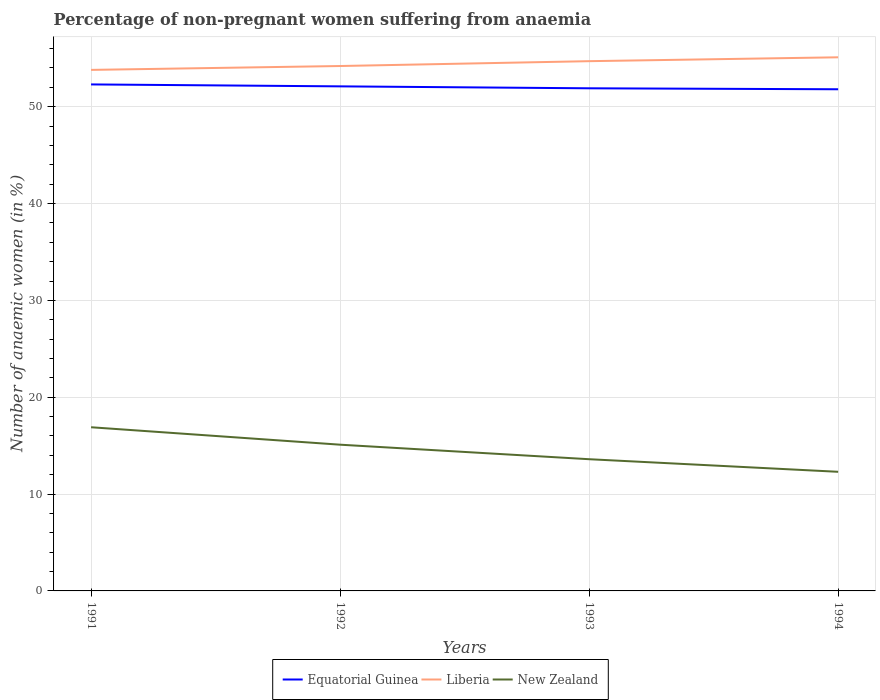Is the number of lines equal to the number of legend labels?
Offer a terse response. Yes. Across all years, what is the maximum percentage of non-pregnant women suffering from anaemia in Equatorial Guinea?
Make the answer very short. 51.8. What is the total percentage of non-pregnant women suffering from anaemia in New Zealand in the graph?
Offer a very short reply. 3.3. What is the difference between the highest and the second highest percentage of non-pregnant women suffering from anaemia in Liberia?
Your answer should be very brief. 1.3. What is the difference between the highest and the lowest percentage of non-pregnant women suffering from anaemia in New Zealand?
Ensure brevity in your answer.  2. Is the percentage of non-pregnant women suffering from anaemia in Liberia strictly greater than the percentage of non-pregnant women suffering from anaemia in New Zealand over the years?
Provide a short and direct response. No. How many lines are there?
Offer a very short reply. 3. What is the difference between two consecutive major ticks on the Y-axis?
Make the answer very short. 10. Does the graph contain any zero values?
Provide a short and direct response. No. Where does the legend appear in the graph?
Offer a terse response. Bottom center. How are the legend labels stacked?
Offer a terse response. Horizontal. What is the title of the graph?
Your response must be concise. Percentage of non-pregnant women suffering from anaemia. What is the label or title of the X-axis?
Give a very brief answer. Years. What is the label or title of the Y-axis?
Ensure brevity in your answer.  Number of anaemic women (in %). What is the Number of anaemic women (in %) of Equatorial Guinea in 1991?
Your answer should be compact. 52.3. What is the Number of anaemic women (in %) of Liberia in 1991?
Your answer should be compact. 53.8. What is the Number of anaemic women (in %) of New Zealand in 1991?
Make the answer very short. 16.9. What is the Number of anaemic women (in %) of Equatorial Guinea in 1992?
Offer a terse response. 52.1. What is the Number of anaemic women (in %) of Liberia in 1992?
Your response must be concise. 54.2. What is the Number of anaemic women (in %) in Equatorial Guinea in 1993?
Offer a very short reply. 51.9. What is the Number of anaemic women (in %) in Liberia in 1993?
Your answer should be compact. 54.7. What is the Number of anaemic women (in %) in New Zealand in 1993?
Ensure brevity in your answer.  13.6. What is the Number of anaemic women (in %) in Equatorial Guinea in 1994?
Offer a terse response. 51.8. What is the Number of anaemic women (in %) in Liberia in 1994?
Give a very brief answer. 55.1. Across all years, what is the maximum Number of anaemic women (in %) of Equatorial Guinea?
Provide a short and direct response. 52.3. Across all years, what is the maximum Number of anaemic women (in %) in Liberia?
Offer a very short reply. 55.1. Across all years, what is the minimum Number of anaemic women (in %) of Equatorial Guinea?
Make the answer very short. 51.8. Across all years, what is the minimum Number of anaemic women (in %) of Liberia?
Offer a very short reply. 53.8. What is the total Number of anaemic women (in %) in Equatorial Guinea in the graph?
Your answer should be very brief. 208.1. What is the total Number of anaemic women (in %) of Liberia in the graph?
Give a very brief answer. 217.8. What is the total Number of anaemic women (in %) in New Zealand in the graph?
Ensure brevity in your answer.  57.9. What is the difference between the Number of anaemic women (in %) in Equatorial Guinea in 1991 and that in 1992?
Offer a very short reply. 0.2. What is the difference between the Number of anaemic women (in %) in Liberia in 1991 and that in 1992?
Your answer should be very brief. -0.4. What is the difference between the Number of anaemic women (in %) in New Zealand in 1991 and that in 1992?
Ensure brevity in your answer.  1.8. What is the difference between the Number of anaemic women (in %) of New Zealand in 1991 and that in 1993?
Make the answer very short. 3.3. What is the difference between the Number of anaemic women (in %) of New Zealand in 1991 and that in 1994?
Ensure brevity in your answer.  4.6. What is the difference between the Number of anaemic women (in %) of Equatorial Guinea in 1992 and that in 1993?
Offer a very short reply. 0.2. What is the difference between the Number of anaemic women (in %) of Liberia in 1992 and that in 1993?
Keep it short and to the point. -0.5. What is the difference between the Number of anaemic women (in %) of New Zealand in 1992 and that in 1993?
Ensure brevity in your answer.  1.5. What is the difference between the Number of anaemic women (in %) of Equatorial Guinea in 1993 and that in 1994?
Provide a succinct answer. 0.1. What is the difference between the Number of anaemic women (in %) of Equatorial Guinea in 1991 and the Number of anaemic women (in %) of New Zealand in 1992?
Your answer should be very brief. 37.2. What is the difference between the Number of anaemic women (in %) of Liberia in 1991 and the Number of anaemic women (in %) of New Zealand in 1992?
Your answer should be very brief. 38.7. What is the difference between the Number of anaemic women (in %) of Equatorial Guinea in 1991 and the Number of anaemic women (in %) of Liberia in 1993?
Provide a short and direct response. -2.4. What is the difference between the Number of anaemic women (in %) of Equatorial Guinea in 1991 and the Number of anaemic women (in %) of New Zealand in 1993?
Provide a succinct answer. 38.7. What is the difference between the Number of anaemic women (in %) of Liberia in 1991 and the Number of anaemic women (in %) of New Zealand in 1993?
Keep it short and to the point. 40.2. What is the difference between the Number of anaemic women (in %) of Equatorial Guinea in 1991 and the Number of anaemic women (in %) of Liberia in 1994?
Give a very brief answer. -2.8. What is the difference between the Number of anaemic women (in %) of Equatorial Guinea in 1991 and the Number of anaemic women (in %) of New Zealand in 1994?
Your response must be concise. 40. What is the difference between the Number of anaemic women (in %) in Liberia in 1991 and the Number of anaemic women (in %) in New Zealand in 1994?
Offer a very short reply. 41.5. What is the difference between the Number of anaemic women (in %) of Equatorial Guinea in 1992 and the Number of anaemic women (in %) of Liberia in 1993?
Your response must be concise. -2.6. What is the difference between the Number of anaemic women (in %) in Equatorial Guinea in 1992 and the Number of anaemic women (in %) in New Zealand in 1993?
Provide a short and direct response. 38.5. What is the difference between the Number of anaemic women (in %) in Liberia in 1992 and the Number of anaemic women (in %) in New Zealand in 1993?
Ensure brevity in your answer.  40.6. What is the difference between the Number of anaemic women (in %) of Equatorial Guinea in 1992 and the Number of anaemic women (in %) of New Zealand in 1994?
Provide a succinct answer. 39.8. What is the difference between the Number of anaemic women (in %) of Liberia in 1992 and the Number of anaemic women (in %) of New Zealand in 1994?
Provide a short and direct response. 41.9. What is the difference between the Number of anaemic women (in %) of Equatorial Guinea in 1993 and the Number of anaemic women (in %) of Liberia in 1994?
Offer a terse response. -3.2. What is the difference between the Number of anaemic women (in %) in Equatorial Guinea in 1993 and the Number of anaemic women (in %) in New Zealand in 1994?
Ensure brevity in your answer.  39.6. What is the difference between the Number of anaemic women (in %) in Liberia in 1993 and the Number of anaemic women (in %) in New Zealand in 1994?
Make the answer very short. 42.4. What is the average Number of anaemic women (in %) in Equatorial Guinea per year?
Make the answer very short. 52.02. What is the average Number of anaemic women (in %) of Liberia per year?
Ensure brevity in your answer.  54.45. What is the average Number of anaemic women (in %) in New Zealand per year?
Your answer should be very brief. 14.47. In the year 1991, what is the difference between the Number of anaemic women (in %) in Equatorial Guinea and Number of anaemic women (in %) in Liberia?
Offer a terse response. -1.5. In the year 1991, what is the difference between the Number of anaemic women (in %) in Equatorial Guinea and Number of anaemic women (in %) in New Zealand?
Offer a terse response. 35.4. In the year 1991, what is the difference between the Number of anaemic women (in %) in Liberia and Number of anaemic women (in %) in New Zealand?
Offer a terse response. 36.9. In the year 1992, what is the difference between the Number of anaemic women (in %) of Liberia and Number of anaemic women (in %) of New Zealand?
Provide a succinct answer. 39.1. In the year 1993, what is the difference between the Number of anaemic women (in %) in Equatorial Guinea and Number of anaemic women (in %) in Liberia?
Ensure brevity in your answer.  -2.8. In the year 1993, what is the difference between the Number of anaemic women (in %) of Equatorial Guinea and Number of anaemic women (in %) of New Zealand?
Keep it short and to the point. 38.3. In the year 1993, what is the difference between the Number of anaemic women (in %) of Liberia and Number of anaemic women (in %) of New Zealand?
Provide a succinct answer. 41.1. In the year 1994, what is the difference between the Number of anaemic women (in %) of Equatorial Guinea and Number of anaemic women (in %) of New Zealand?
Make the answer very short. 39.5. In the year 1994, what is the difference between the Number of anaemic women (in %) in Liberia and Number of anaemic women (in %) in New Zealand?
Provide a short and direct response. 42.8. What is the ratio of the Number of anaemic women (in %) in Equatorial Guinea in 1991 to that in 1992?
Provide a short and direct response. 1. What is the ratio of the Number of anaemic women (in %) in Liberia in 1991 to that in 1992?
Provide a succinct answer. 0.99. What is the ratio of the Number of anaemic women (in %) in New Zealand in 1991 to that in 1992?
Provide a short and direct response. 1.12. What is the ratio of the Number of anaemic women (in %) of Equatorial Guinea in 1991 to that in 1993?
Offer a very short reply. 1.01. What is the ratio of the Number of anaemic women (in %) in Liberia in 1991 to that in 1993?
Your response must be concise. 0.98. What is the ratio of the Number of anaemic women (in %) in New Zealand in 1991 to that in 1993?
Offer a very short reply. 1.24. What is the ratio of the Number of anaemic women (in %) of Equatorial Guinea in 1991 to that in 1994?
Your answer should be compact. 1.01. What is the ratio of the Number of anaemic women (in %) in Liberia in 1991 to that in 1994?
Your answer should be compact. 0.98. What is the ratio of the Number of anaemic women (in %) of New Zealand in 1991 to that in 1994?
Provide a succinct answer. 1.37. What is the ratio of the Number of anaemic women (in %) of Equatorial Guinea in 1992 to that in 1993?
Provide a short and direct response. 1. What is the ratio of the Number of anaemic women (in %) of Liberia in 1992 to that in 1993?
Your answer should be compact. 0.99. What is the ratio of the Number of anaemic women (in %) of New Zealand in 1992 to that in 1993?
Your answer should be compact. 1.11. What is the ratio of the Number of anaemic women (in %) in Equatorial Guinea in 1992 to that in 1994?
Give a very brief answer. 1.01. What is the ratio of the Number of anaemic women (in %) in Liberia in 1992 to that in 1994?
Your response must be concise. 0.98. What is the ratio of the Number of anaemic women (in %) in New Zealand in 1992 to that in 1994?
Offer a terse response. 1.23. What is the ratio of the Number of anaemic women (in %) of New Zealand in 1993 to that in 1994?
Make the answer very short. 1.11. What is the difference between the highest and the second highest Number of anaemic women (in %) of Equatorial Guinea?
Your answer should be very brief. 0.2. What is the difference between the highest and the second highest Number of anaemic women (in %) in New Zealand?
Provide a succinct answer. 1.8. What is the difference between the highest and the lowest Number of anaemic women (in %) in Equatorial Guinea?
Provide a succinct answer. 0.5. What is the difference between the highest and the lowest Number of anaemic women (in %) in Liberia?
Ensure brevity in your answer.  1.3. 